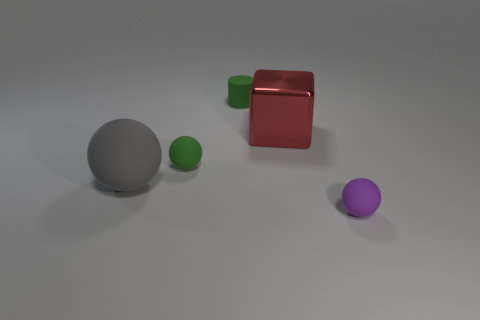What is the color of the matte object that is the same size as the block?
Keep it short and to the point. Gray. How many other things are the same shape as the metal object?
Your response must be concise. 0. What size is the green object that is behind the tiny green sphere?
Offer a very short reply. Small. There is a big thing behind the big matte object; what number of large matte spheres are to the left of it?
Your answer should be very brief. 1. How many other objects are the same size as the red block?
Offer a very short reply. 1. Is the matte cylinder the same color as the shiny block?
Ensure brevity in your answer.  No. Do the large thing left of the big red cube and the red metallic thing have the same shape?
Give a very brief answer. No. What number of things are left of the metallic thing and behind the green sphere?
Offer a terse response. 1. What material is the tiny green ball?
Ensure brevity in your answer.  Rubber. Is there any other thing that is the same color as the matte cylinder?
Keep it short and to the point. Yes. 